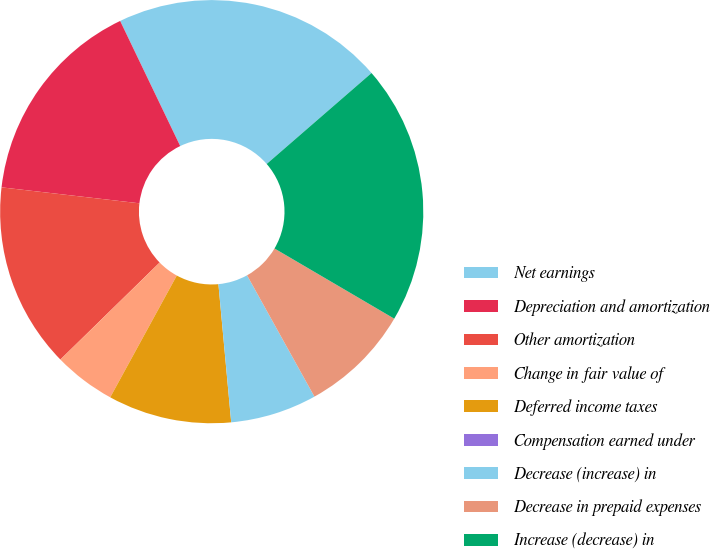Convert chart to OTSL. <chart><loc_0><loc_0><loc_500><loc_500><pie_chart><fcel>Net earnings<fcel>Depreciation and amortization<fcel>Other amortization<fcel>Change in fair value of<fcel>Deferred income taxes<fcel>Compensation earned under<fcel>Decrease (increase) in<fcel>Decrease in prepaid expenses<fcel>Increase (decrease) in<nl><fcel>20.75%<fcel>16.04%<fcel>14.15%<fcel>4.72%<fcel>9.43%<fcel>0.0%<fcel>6.6%<fcel>8.49%<fcel>19.81%<nl></chart> 